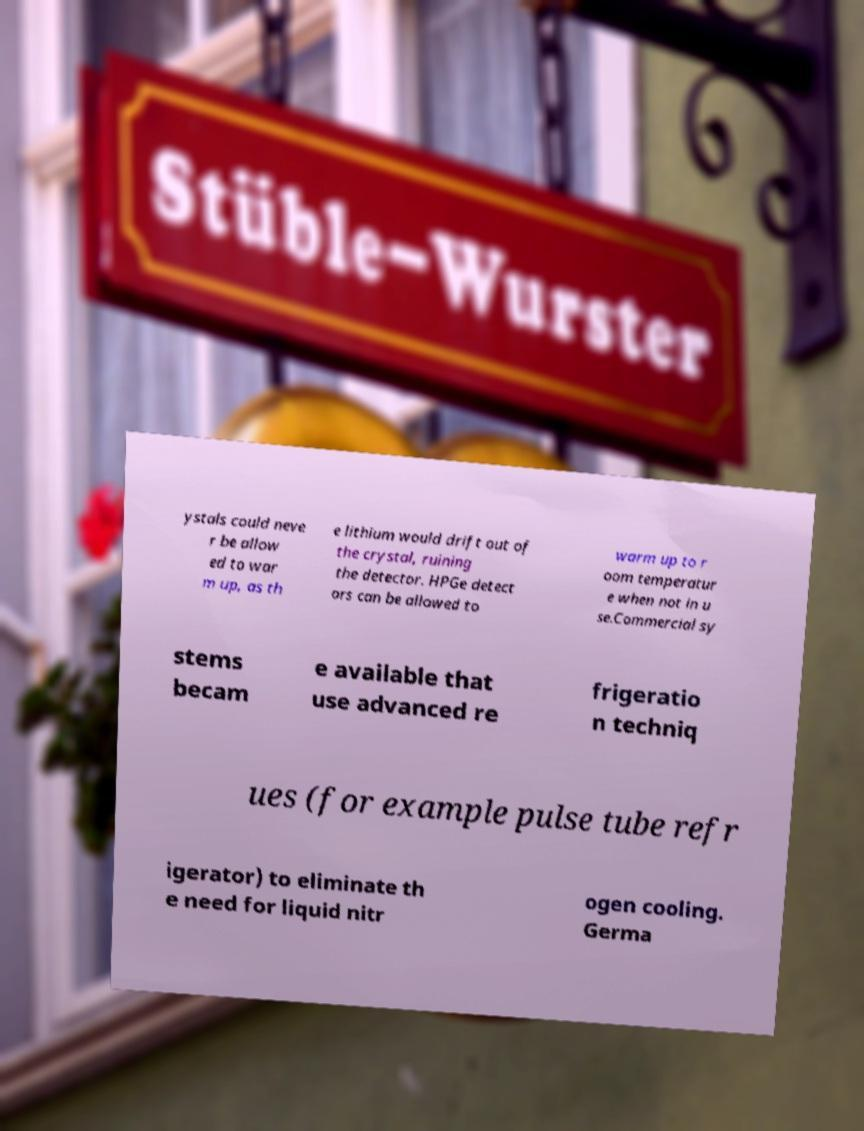Please identify and transcribe the text found in this image. ystals could neve r be allow ed to war m up, as th e lithium would drift out of the crystal, ruining the detector. HPGe detect ors can be allowed to warm up to r oom temperatur e when not in u se.Commercial sy stems becam e available that use advanced re frigeratio n techniq ues (for example pulse tube refr igerator) to eliminate th e need for liquid nitr ogen cooling. Germa 